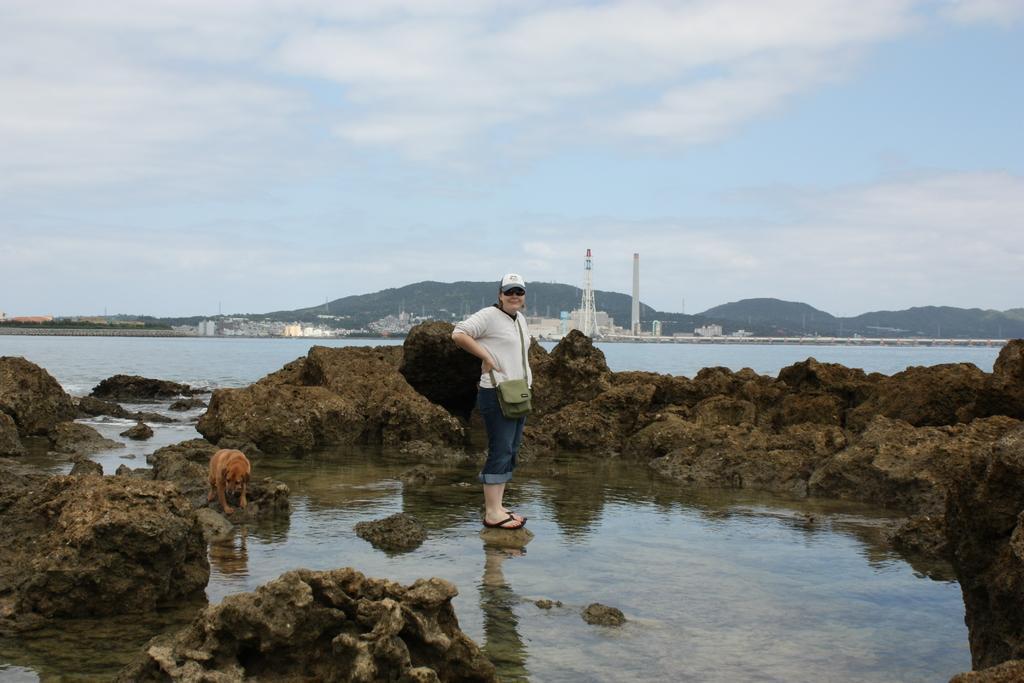In one or two sentences, can you explain what this image depicts? In this picture there is a lady who is standing in the center of the image and there is a dog on the left side of the image and there are rocks at the bottom side of the image, there is water in the center of the image and there are towers, buildings, and trees in the background area of the image. 